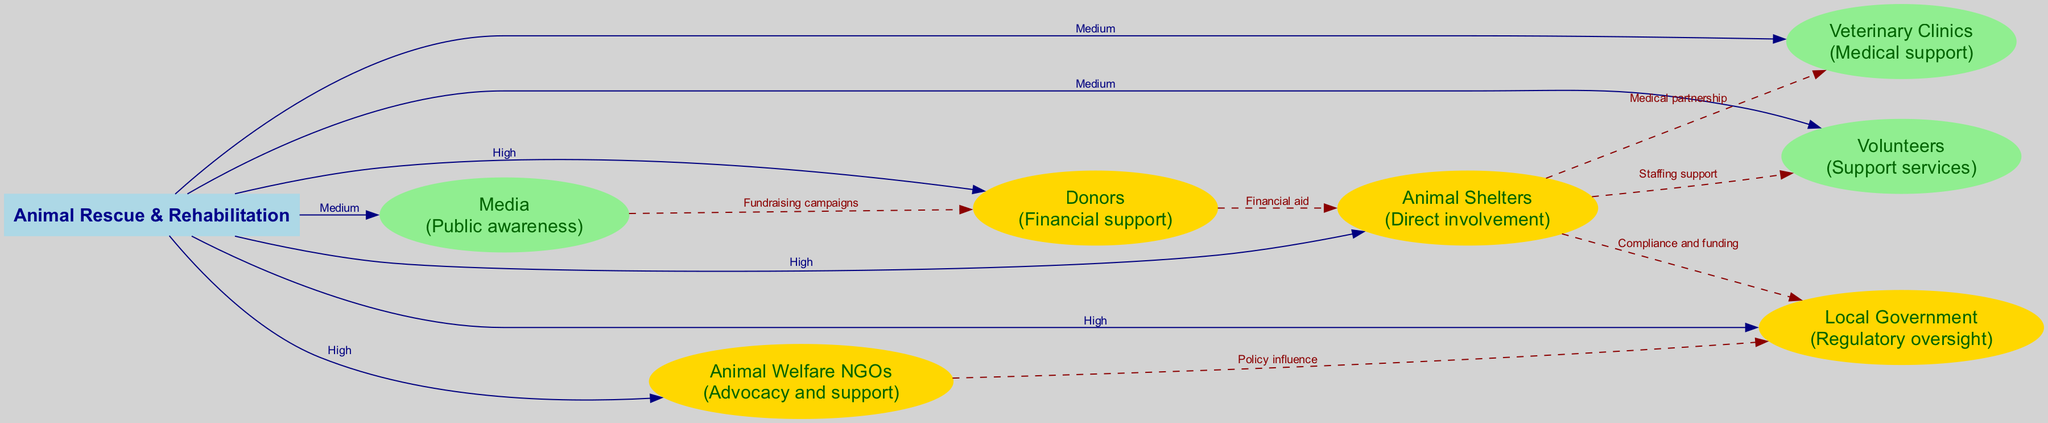What is the central node of the diagram? The central node is "Animal Rescue & Rehabilitation", which serves as the main focus of the stakeholder analysis or interest. This is clearly labeled in the center of the diagram.
Answer: Animal Rescue & Rehabilitation How many stakeholders are present in the diagram? The diagram lists a total of six stakeholders involved in animal rescue and rehabilitation efforts, as shown in the stakeholder section.
Answer: Six What is the relationship between Animal Shelters and Veterinary Clinics? The relationship is labeled as "Medical partnership", indicating that Animal Shelters directly work with Veterinary Clinics for medical needs. This connection is shown as an edge in the diagram.
Answer: Medical partnership Which stakeholder has the highest influence? The stakeholders with the highest influence include "Animal Shelters", "Local Government", "Donors", and "Animal Welfare NGOs", all marked in gold. Each has a significant role in the overall system.
Answer: Animal Shelters, Local Government, Donors, Animal Welfare NGOs What color represents stakeholders with medium influence? The stakeholders with medium influence are represented in light green color. This color coding helps distinguish the varying levels of influence quickly in the diagram.
Answer: Light green How do Media and Donors interact according to the diagram? Their interaction is labeled as "Fundraising campaigns", indicating a collaborative effort where Media supports Donors in raising financial resources for animal rescue. This is shown as a dashed connection in the diagram.
Answer: Fundraising campaigns What is the influence level of Veterinary Clinics? The influence of Veterinary Clinics is marked as "Medium", which indicates they have a supportive but less critical role compared to those with high influence like Animal Shelters or Donors.
Answer: Medium What type of support do Volunteers provide according to their relationship? Volunteers provide "Support services", which indicates their role in assisting the primary stakeholders, particularly Animal Shelters, though their contribution is classified with medium influence.
Answer: Support services 